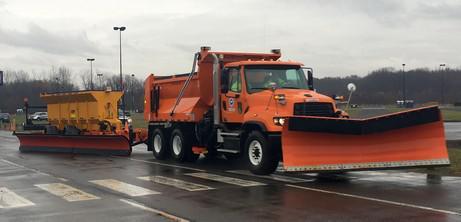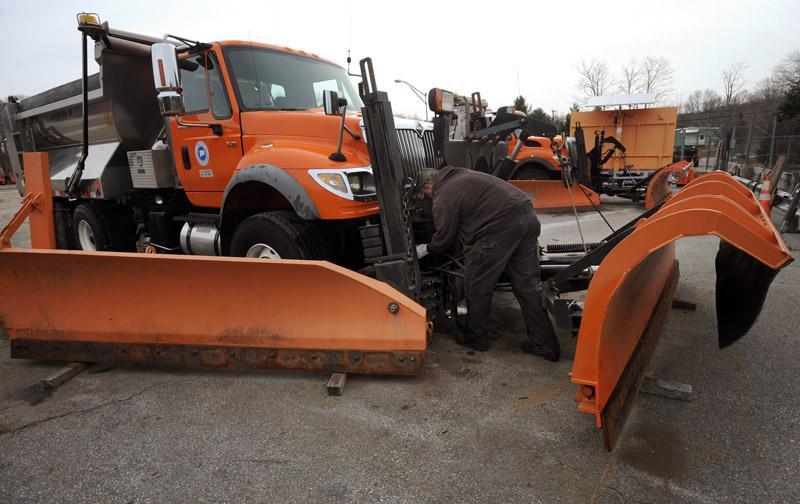The first image is the image on the left, the second image is the image on the right. Analyze the images presented: Is the assertion "Only one of the images features a red truck, with a plow attachment." valid? Answer yes or no. No. The first image is the image on the left, the second image is the image on the right. Given the left and right images, does the statement "A truck in each image is equipped with a front-facing orange show blade, but neither truck is plowing snow." hold true? Answer yes or no. Yes. 